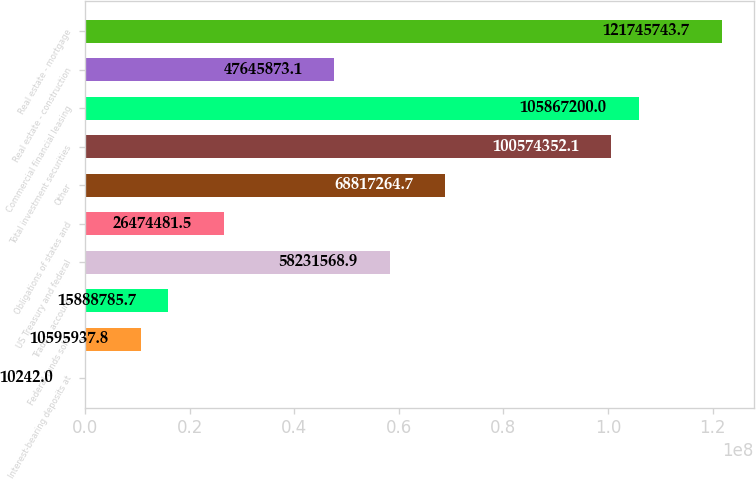Convert chart. <chart><loc_0><loc_0><loc_500><loc_500><bar_chart><fcel>Interest-bearing deposits at<fcel>Federal funds sold<fcel>Trading account<fcel>US Treasury and federal<fcel>Obligations of states and<fcel>Other<fcel>Total investment securities<fcel>Commercial financial leasing<fcel>Real estate - construction<fcel>Real estate - mortgage<nl><fcel>10242<fcel>1.05959e+07<fcel>1.58888e+07<fcel>5.82316e+07<fcel>2.64745e+07<fcel>6.88173e+07<fcel>1.00574e+08<fcel>1.05867e+08<fcel>4.76459e+07<fcel>1.21746e+08<nl></chart> 